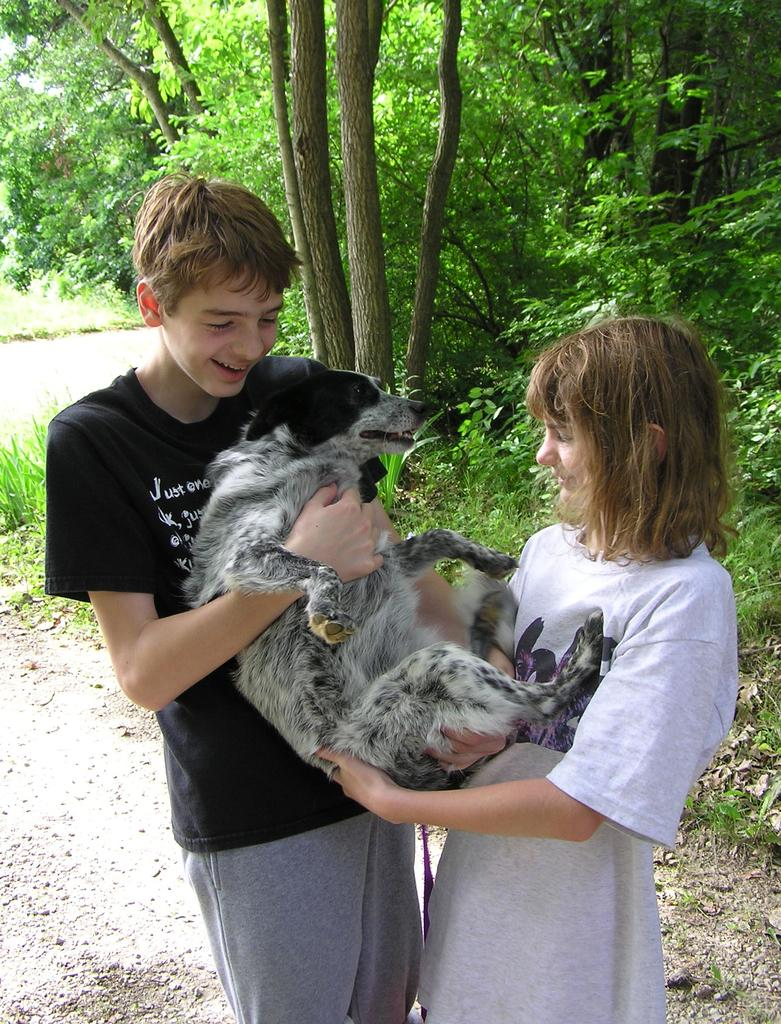Who is present in the image? There is a boy and a girl in the image. What are they doing in the image? The boy and girl are holding a dog in their hands. What is the dog's position in relation to the boy and girl? The dog is in their hands. What is the ground like in the image? They are standing on the ground. What is the emotional expression of the boy and girl? They are smiling. What can be seen in the background of the image? There are trees in the background of the image. What type of bulb is hanging from the tree in the image? There is no bulb present in the image; it features a boy, a girl, and a dog. What color is the hat worn by the dog in the image? There is no hat present on the dog in the image. 